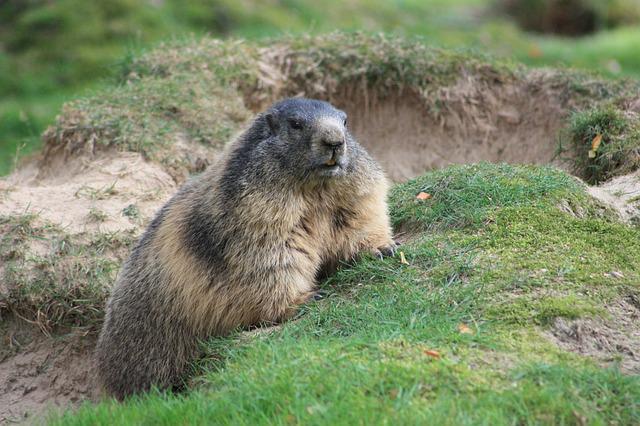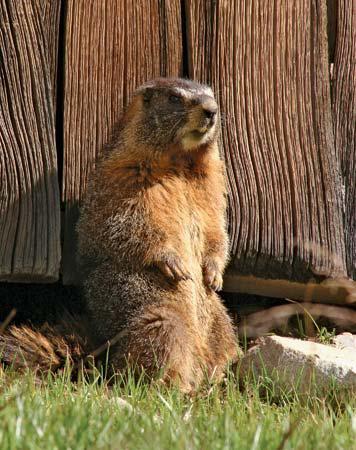The first image is the image on the left, the second image is the image on the right. Given the left and right images, does the statement "The animal in the image on  the right is standing on its hind legs." hold true? Answer yes or no. Yes. The first image is the image on the left, the second image is the image on the right. For the images displayed, is the sentence "An image features an upright marmot with something clasped in its paws at mouth-level." factually correct? Answer yes or no. No. 